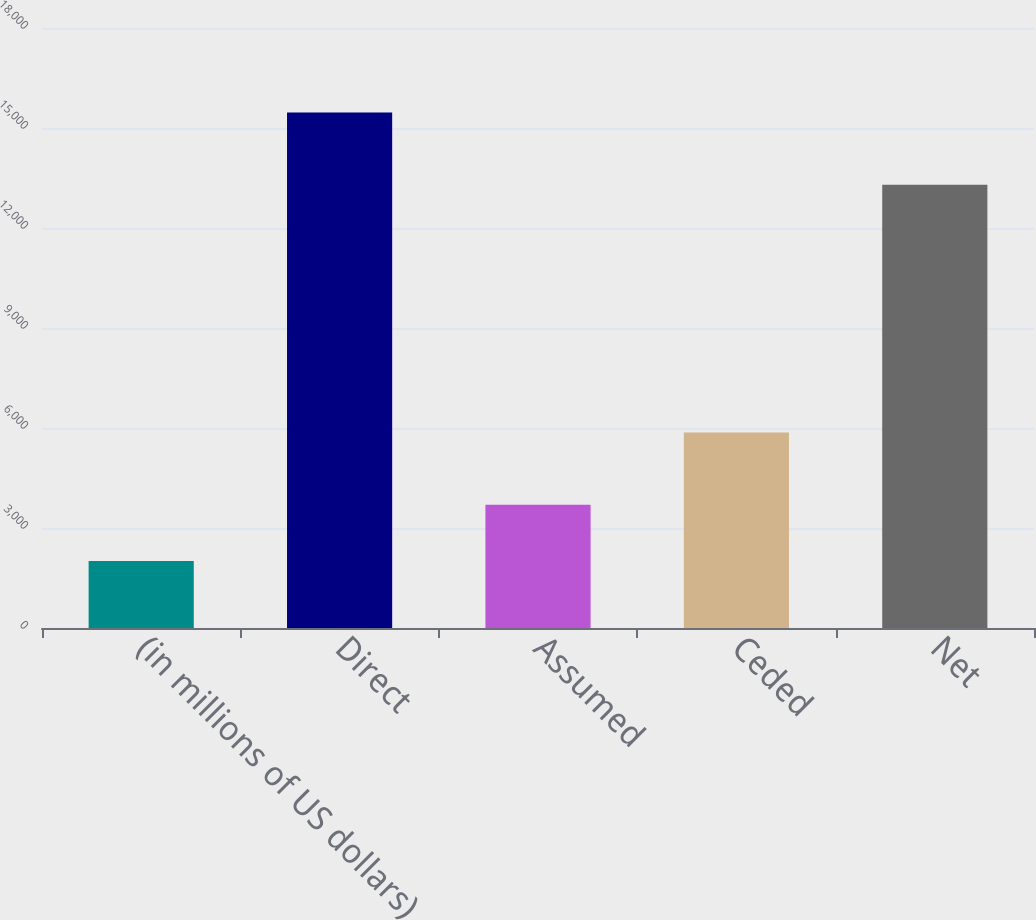<chart> <loc_0><loc_0><loc_500><loc_500><bar_chart><fcel>(in millions of US dollars)<fcel>Direct<fcel>Assumed<fcel>Ceded<fcel>Net<nl><fcel>2009<fcel>15467<fcel>3697<fcel>5865<fcel>13299<nl></chart> 